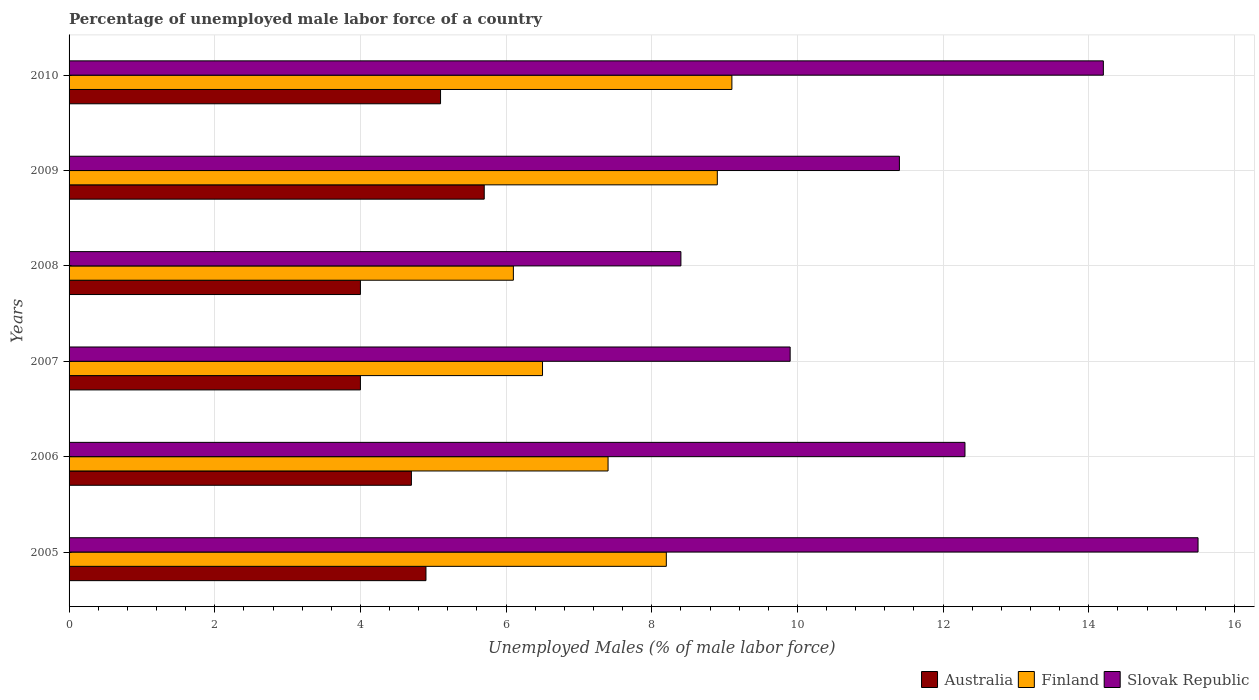How many groups of bars are there?
Keep it short and to the point. 6. Are the number of bars on each tick of the Y-axis equal?
Provide a succinct answer. Yes. How many bars are there on the 6th tick from the top?
Your answer should be compact. 3. What is the label of the 1st group of bars from the top?
Keep it short and to the point. 2010. In how many cases, is the number of bars for a given year not equal to the number of legend labels?
Give a very brief answer. 0. What is the percentage of unemployed male labor force in Australia in 2010?
Offer a very short reply. 5.1. Across all years, what is the maximum percentage of unemployed male labor force in Finland?
Offer a terse response. 9.1. Across all years, what is the minimum percentage of unemployed male labor force in Australia?
Provide a short and direct response. 4. What is the total percentage of unemployed male labor force in Australia in the graph?
Your answer should be very brief. 28.4. What is the difference between the percentage of unemployed male labor force in Australia in 2007 and that in 2010?
Provide a succinct answer. -1.1. What is the difference between the percentage of unemployed male labor force in Slovak Republic in 2006 and the percentage of unemployed male labor force in Finland in 2009?
Ensure brevity in your answer.  3.4. What is the average percentage of unemployed male labor force in Slovak Republic per year?
Offer a very short reply. 11.95. In the year 2008, what is the difference between the percentage of unemployed male labor force in Finland and percentage of unemployed male labor force in Slovak Republic?
Offer a terse response. -2.3. In how many years, is the percentage of unemployed male labor force in Australia greater than 9.6 %?
Make the answer very short. 0. What is the ratio of the percentage of unemployed male labor force in Finland in 2006 to that in 2008?
Give a very brief answer. 1.21. What is the difference between the highest and the second highest percentage of unemployed male labor force in Australia?
Your response must be concise. 0.6. What is the difference between the highest and the lowest percentage of unemployed male labor force in Finland?
Offer a very short reply. 3. In how many years, is the percentage of unemployed male labor force in Slovak Republic greater than the average percentage of unemployed male labor force in Slovak Republic taken over all years?
Your answer should be compact. 3. Is the sum of the percentage of unemployed male labor force in Australia in 2005 and 2007 greater than the maximum percentage of unemployed male labor force in Slovak Republic across all years?
Make the answer very short. No. How many bars are there?
Offer a terse response. 18. Are all the bars in the graph horizontal?
Keep it short and to the point. Yes. Are the values on the major ticks of X-axis written in scientific E-notation?
Your answer should be compact. No. Does the graph contain grids?
Your answer should be compact. Yes. How are the legend labels stacked?
Your answer should be very brief. Horizontal. What is the title of the graph?
Make the answer very short. Percentage of unemployed male labor force of a country. What is the label or title of the X-axis?
Provide a short and direct response. Unemployed Males (% of male labor force). What is the label or title of the Y-axis?
Provide a succinct answer. Years. What is the Unemployed Males (% of male labor force) of Australia in 2005?
Keep it short and to the point. 4.9. What is the Unemployed Males (% of male labor force) of Finland in 2005?
Provide a short and direct response. 8.2. What is the Unemployed Males (% of male labor force) of Australia in 2006?
Give a very brief answer. 4.7. What is the Unemployed Males (% of male labor force) in Finland in 2006?
Your answer should be compact. 7.4. What is the Unemployed Males (% of male labor force) of Slovak Republic in 2006?
Keep it short and to the point. 12.3. What is the Unemployed Males (% of male labor force) in Australia in 2007?
Ensure brevity in your answer.  4. What is the Unemployed Males (% of male labor force) of Slovak Republic in 2007?
Give a very brief answer. 9.9. What is the Unemployed Males (% of male labor force) of Australia in 2008?
Your answer should be compact. 4. What is the Unemployed Males (% of male labor force) in Finland in 2008?
Make the answer very short. 6.1. What is the Unemployed Males (% of male labor force) in Slovak Republic in 2008?
Provide a succinct answer. 8.4. What is the Unemployed Males (% of male labor force) in Australia in 2009?
Provide a succinct answer. 5.7. What is the Unemployed Males (% of male labor force) of Finland in 2009?
Your response must be concise. 8.9. What is the Unemployed Males (% of male labor force) of Slovak Republic in 2009?
Give a very brief answer. 11.4. What is the Unemployed Males (% of male labor force) in Australia in 2010?
Offer a terse response. 5.1. What is the Unemployed Males (% of male labor force) of Finland in 2010?
Give a very brief answer. 9.1. What is the Unemployed Males (% of male labor force) of Slovak Republic in 2010?
Your answer should be compact. 14.2. Across all years, what is the maximum Unemployed Males (% of male labor force) of Australia?
Make the answer very short. 5.7. Across all years, what is the maximum Unemployed Males (% of male labor force) of Finland?
Offer a very short reply. 9.1. Across all years, what is the maximum Unemployed Males (% of male labor force) in Slovak Republic?
Make the answer very short. 15.5. Across all years, what is the minimum Unemployed Males (% of male labor force) in Australia?
Your answer should be compact. 4. Across all years, what is the minimum Unemployed Males (% of male labor force) of Finland?
Give a very brief answer. 6.1. Across all years, what is the minimum Unemployed Males (% of male labor force) in Slovak Republic?
Offer a terse response. 8.4. What is the total Unemployed Males (% of male labor force) of Australia in the graph?
Your response must be concise. 28.4. What is the total Unemployed Males (% of male labor force) of Finland in the graph?
Your response must be concise. 46.2. What is the total Unemployed Males (% of male labor force) of Slovak Republic in the graph?
Keep it short and to the point. 71.7. What is the difference between the Unemployed Males (% of male labor force) of Australia in 2005 and that in 2006?
Ensure brevity in your answer.  0.2. What is the difference between the Unemployed Males (% of male labor force) of Slovak Republic in 2005 and that in 2006?
Offer a very short reply. 3.2. What is the difference between the Unemployed Males (% of male labor force) of Australia in 2005 and that in 2007?
Offer a very short reply. 0.9. What is the difference between the Unemployed Males (% of male labor force) in Finland in 2005 and that in 2007?
Ensure brevity in your answer.  1.7. What is the difference between the Unemployed Males (% of male labor force) in Australia in 2005 and that in 2009?
Provide a short and direct response. -0.8. What is the difference between the Unemployed Males (% of male labor force) of Finland in 2005 and that in 2009?
Offer a very short reply. -0.7. What is the difference between the Unemployed Males (% of male labor force) in Australia in 2005 and that in 2010?
Make the answer very short. -0.2. What is the difference between the Unemployed Males (% of male labor force) of Slovak Republic in 2005 and that in 2010?
Offer a terse response. 1.3. What is the difference between the Unemployed Males (% of male labor force) in Australia in 2006 and that in 2007?
Your answer should be compact. 0.7. What is the difference between the Unemployed Males (% of male labor force) in Finland in 2006 and that in 2007?
Your answer should be very brief. 0.9. What is the difference between the Unemployed Males (% of male labor force) of Slovak Republic in 2006 and that in 2008?
Ensure brevity in your answer.  3.9. What is the difference between the Unemployed Males (% of male labor force) of Australia in 2006 and that in 2009?
Your response must be concise. -1. What is the difference between the Unemployed Males (% of male labor force) in Australia in 2006 and that in 2010?
Make the answer very short. -0.4. What is the difference between the Unemployed Males (% of male labor force) in Slovak Republic in 2006 and that in 2010?
Provide a short and direct response. -1.9. What is the difference between the Unemployed Males (% of male labor force) in Australia in 2007 and that in 2008?
Offer a very short reply. 0. What is the difference between the Unemployed Males (% of male labor force) in Finland in 2007 and that in 2008?
Give a very brief answer. 0.4. What is the difference between the Unemployed Males (% of male labor force) of Slovak Republic in 2007 and that in 2008?
Keep it short and to the point. 1.5. What is the difference between the Unemployed Males (% of male labor force) in Slovak Republic in 2007 and that in 2009?
Your response must be concise. -1.5. What is the difference between the Unemployed Males (% of male labor force) in Australia in 2007 and that in 2010?
Keep it short and to the point. -1.1. What is the difference between the Unemployed Males (% of male labor force) of Slovak Republic in 2007 and that in 2010?
Your response must be concise. -4.3. What is the difference between the Unemployed Males (% of male labor force) of Finland in 2008 and that in 2009?
Your response must be concise. -2.8. What is the difference between the Unemployed Males (% of male labor force) of Slovak Republic in 2008 and that in 2009?
Offer a terse response. -3. What is the difference between the Unemployed Males (% of male labor force) of Australia in 2008 and that in 2010?
Ensure brevity in your answer.  -1.1. What is the difference between the Unemployed Males (% of male labor force) in Finland in 2008 and that in 2010?
Ensure brevity in your answer.  -3. What is the difference between the Unemployed Males (% of male labor force) of Slovak Republic in 2008 and that in 2010?
Provide a succinct answer. -5.8. What is the difference between the Unemployed Males (% of male labor force) of Australia in 2009 and that in 2010?
Give a very brief answer. 0.6. What is the difference between the Unemployed Males (% of male labor force) in Finland in 2009 and that in 2010?
Make the answer very short. -0.2. What is the difference between the Unemployed Males (% of male labor force) in Slovak Republic in 2009 and that in 2010?
Make the answer very short. -2.8. What is the difference between the Unemployed Males (% of male labor force) of Australia in 2005 and the Unemployed Males (% of male labor force) of Finland in 2006?
Offer a terse response. -2.5. What is the difference between the Unemployed Males (% of male labor force) of Finland in 2005 and the Unemployed Males (% of male labor force) of Slovak Republic in 2006?
Make the answer very short. -4.1. What is the difference between the Unemployed Males (% of male labor force) in Australia in 2005 and the Unemployed Males (% of male labor force) in Finland in 2007?
Provide a succinct answer. -1.6. What is the difference between the Unemployed Males (% of male labor force) of Australia in 2005 and the Unemployed Males (% of male labor force) of Slovak Republic in 2008?
Make the answer very short. -3.5. What is the difference between the Unemployed Males (% of male labor force) of Finland in 2005 and the Unemployed Males (% of male labor force) of Slovak Republic in 2008?
Provide a short and direct response. -0.2. What is the difference between the Unemployed Males (% of male labor force) of Australia in 2005 and the Unemployed Males (% of male labor force) of Finland in 2009?
Provide a succinct answer. -4. What is the difference between the Unemployed Males (% of male labor force) in Finland in 2005 and the Unemployed Males (% of male labor force) in Slovak Republic in 2009?
Your response must be concise. -3.2. What is the difference between the Unemployed Males (% of male labor force) of Australia in 2005 and the Unemployed Males (% of male labor force) of Finland in 2010?
Your response must be concise. -4.2. What is the difference between the Unemployed Males (% of male labor force) in Finland in 2005 and the Unemployed Males (% of male labor force) in Slovak Republic in 2010?
Ensure brevity in your answer.  -6. What is the difference between the Unemployed Males (% of male labor force) of Australia in 2006 and the Unemployed Males (% of male labor force) of Finland in 2007?
Offer a terse response. -1.8. What is the difference between the Unemployed Males (% of male labor force) of Australia in 2006 and the Unemployed Males (% of male labor force) of Slovak Republic in 2007?
Provide a short and direct response. -5.2. What is the difference between the Unemployed Males (% of male labor force) in Finland in 2006 and the Unemployed Males (% of male labor force) in Slovak Republic in 2007?
Provide a short and direct response. -2.5. What is the difference between the Unemployed Males (% of male labor force) in Finland in 2006 and the Unemployed Males (% of male labor force) in Slovak Republic in 2008?
Your answer should be very brief. -1. What is the difference between the Unemployed Males (% of male labor force) in Australia in 2006 and the Unemployed Males (% of male labor force) in Finland in 2009?
Make the answer very short. -4.2. What is the difference between the Unemployed Males (% of male labor force) of Australia in 2007 and the Unemployed Males (% of male labor force) of Slovak Republic in 2008?
Give a very brief answer. -4.4. What is the difference between the Unemployed Males (% of male labor force) of Australia in 2007 and the Unemployed Males (% of male labor force) of Slovak Republic in 2009?
Offer a terse response. -7.4. What is the difference between the Unemployed Males (% of male labor force) of Finland in 2007 and the Unemployed Males (% of male labor force) of Slovak Republic in 2009?
Offer a terse response. -4.9. What is the difference between the Unemployed Males (% of male labor force) of Australia in 2007 and the Unemployed Males (% of male labor force) of Finland in 2010?
Give a very brief answer. -5.1. What is the difference between the Unemployed Males (% of male labor force) of Australia in 2008 and the Unemployed Males (% of male labor force) of Finland in 2009?
Ensure brevity in your answer.  -4.9. What is the difference between the Unemployed Males (% of male labor force) in Finland in 2008 and the Unemployed Males (% of male labor force) in Slovak Republic in 2009?
Provide a short and direct response. -5.3. What is the difference between the Unemployed Males (% of male labor force) of Finland in 2008 and the Unemployed Males (% of male labor force) of Slovak Republic in 2010?
Provide a short and direct response. -8.1. What is the average Unemployed Males (% of male labor force) in Australia per year?
Give a very brief answer. 4.73. What is the average Unemployed Males (% of male labor force) of Finland per year?
Keep it short and to the point. 7.7. What is the average Unemployed Males (% of male labor force) of Slovak Republic per year?
Keep it short and to the point. 11.95. In the year 2005, what is the difference between the Unemployed Males (% of male labor force) of Finland and Unemployed Males (% of male labor force) of Slovak Republic?
Your response must be concise. -7.3. In the year 2006, what is the difference between the Unemployed Males (% of male labor force) in Australia and Unemployed Males (% of male labor force) in Finland?
Your answer should be very brief. -2.7. In the year 2006, what is the difference between the Unemployed Males (% of male labor force) of Australia and Unemployed Males (% of male labor force) of Slovak Republic?
Ensure brevity in your answer.  -7.6. In the year 2006, what is the difference between the Unemployed Males (% of male labor force) in Finland and Unemployed Males (% of male labor force) in Slovak Republic?
Your response must be concise. -4.9. In the year 2007, what is the difference between the Unemployed Males (% of male labor force) in Australia and Unemployed Males (% of male labor force) in Finland?
Make the answer very short. -2.5. In the year 2007, what is the difference between the Unemployed Males (% of male labor force) of Finland and Unemployed Males (% of male labor force) of Slovak Republic?
Your answer should be compact. -3.4. In the year 2008, what is the difference between the Unemployed Males (% of male labor force) in Australia and Unemployed Males (% of male labor force) in Finland?
Provide a short and direct response. -2.1. In the year 2008, what is the difference between the Unemployed Males (% of male labor force) of Finland and Unemployed Males (% of male labor force) of Slovak Republic?
Your answer should be very brief. -2.3. In the year 2009, what is the difference between the Unemployed Males (% of male labor force) of Australia and Unemployed Males (% of male labor force) of Finland?
Make the answer very short. -3.2. In the year 2009, what is the difference between the Unemployed Males (% of male labor force) of Australia and Unemployed Males (% of male labor force) of Slovak Republic?
Offer a very short reply. -5.7. In the year 2009, what is the difference between the Unemployed Males (% of male labor force) of Finland and Unemployed Males (% of male labor force) of Slovak Republic?
Your answer should be compact. -2.5. In the year 2010, what is the difference between the Unemployed Males (% of male labor force) in Australia and Unemployed Males (% of male labor force) in Slovak Republic?
Give a very brief answer. -9.1. What is the ratio of the Unemployed Males (% of male labor force) of Australia in 2005 to that in 2006?
Your answer should be very brief. 1.04. What is the ratio of the Unemployed Males (% of male labor force) of Finland in 2005 to that in 2006?
Provide a short and direct response. 1.11. What is the ratio of the Unemployed Males (% of male labor force) in Slovak Republic in 2005 to that in 2006?
Keep it short and to the point. 1.26. What is the ratio of the Unemployed Males (% of male labor force) in Australia in 2005 to that in 2007?
Your response must be concise. 1.23. What is the ratio of the Unemployed Males (% of male labor force) in Finland in 2005 to that in 2007?
Your answer should be very brief. 1.26. What is the ratio of the Unemployed Males (% of male labor force) of Slovak Republic in 2005 to that in 2007?
Your response must be concise. 1.57. What is the ratio of the Unemployed Males (% of male labor force) in Australia in 2005 to that in 2008?
Provide a short and direct response. 1.23. What is the ratio of the Unemployed Males (% of male labor force) of Finland in 2005 to that in 2008?
Offer a terse response. 1.34. What is the ratio of the Unemployed Males (% of male labor force) in Slovak Republic in 2005 to that in 2008?
Provide a short and direct response. 1.85. What is the ratio of the Unemployed Males (% of male labor force) of Australia in 2005 to that in 2009?
Keep it short and to the point. 0.86. What is the ratio of the Unemployed Males (% of male labor force) in Finland in 2005 to that in 2009?
Your response must be concise. 0.92. What is the ratio of the Unemployed Males (% of male labor force) of Slovak Republic in 2005 to that in 2009?
Provide a short and direct response. 1.36. What is the ratio of the Unemployed Males (% of male labor force) in Australia in 2005 to that in 2010?
Give a very brief answer. 0.96. What is the ratio of the Unemployed Males (% of male labor force) of Finland in 2005 to that in 2010?
Keep it short and to the point. 0.9. What is the ratio of the Unemployed Males (% of male labor force) of Slovak Republic in 2005 to that in 2010?
Ensure brevity in your answer.  1.09. What is the ratio of the Unemployed Males (% of male labor force) of Australia in 2006 to that in 2007?
Make the answer very short. 1.18. What is the ratio of the Unemployed Males (% of male labor force) of Finland in 2006 to that in 2007?
Make the answer very short. 1.14. What is the ratio of the Unemployed Males (% of male labor force) of Slovak Republic in 2006 to that in 2007?
Your answer should be compact. 1.24. What is the ratio of the Unemployed Males (% of male labor force) in Australia in 2006 to that in 2008?
Ensure brevity in your answer.  1.18. What is the ratio of the Unemployed Males (% of male labor force) in Finland in 2006 to that in 2008?
Your answer should be compact. 1.21. What is the ratio of the Unemployed Males (% of male labor force) of Slovak Republic in 2006 to that in 2008?
Your response must be concise. 1.46. What is the ratio of the Unemployed Males (% of male labor force) of Australia in 2006 to that in 2009?
Your answer should be very brief. 0.82. What is the ratio of the Unemployed Males (% of male labor force) of Finland in 2006 to that in 2009?
Your response must be concise. 0.83. What is the ratio of the Unemployed Males (% of male labor force) of Slovak Republic in 2006 to that in 2009?
Make the answer very short. 1.08. What is the ratio of the Unemployed Males (% of male labor force) of Australia in 2006 to that in 2010?
Your answer should be compact. 0.92. What is the ratio of the Unemployed Males (% of male labor force) in Finland in 2006 to that in 2010?
Your answer should be compact. 0.81. What is the ratio of the Unemployed Males (% of male labor force) of Slovak Republic in 2006 to that in 2010?
Offer a terse response. 0.87. What is the ratio of the Unemployed Males (% of male labor force) in Finland in 2007 to that in 2008?
Ensure brevity in your answer.  1.07. What is the ratio of the Unemployed Males (% of male labor force) of Slovak Republic in 2007 to that in 2008?
Your response must be concise. 1.18. What is the ratio of the Unemployed Males (% of male labor force) of Australia in 2007 to that in 2009?
Your answer should be compact. 0.7. What is the ratio of the Unemployed Males (% of male labor force) in Finland in 2007 to that in 2009?
Keep it short and to the point. 0.73. What is the ratio of the Unemployed Males (% of male labor force) of Slovak Republic in 2007 to that in 2009?
Provide a short and direct response. 0.87. What is the ratio of the Unemployed Males (% of male labor force) in Australia in 2007 to that in 2010?
Provide a short and direct response. 0.78. What is the ratio of the Unemployed Males (% of male labor force) of Finland in 2007 to that in 2010?
Give a very brief answer. 0.71. What is the ratio of the Unemployed Males (% of male labor force) in Slovak Republic in 2007 to that in 2010?
Your response must be concise. 0.7. What is the ratio of the Unemployed Males (% of male labor force) of Australia in 2008 to that in 2009?
Your answer should be compact. 0.7. What is the ratio of the Unemployed Males (% of male labor force) in Finland in 2008 to that in 2009?
Give a very brief answer. 0.69. What is the ratio of the Unemployed Males (% of male labor force) of Slovak Republic in 2008 to that in 2009?
Your answer should be compact. 0.74. What is the ratio of the Unemployed Males (% of male labor force) in Australia in 2008 to that in 2010?
Give a very brief answer. 0.78. What is the ratio of the Unemployed Males (% of male labor force) of Finland in 2008 to that in 2010?
Make the answer very short. 0.67. What is the ratio of the Unemployed Males (% of male labor force) of Slovak Republic in 2008 to that in 2010?
Your answer should be very brief. 0.59. What is the ratio of the Unemployed Males (% of male labor force) in Australia in 2009 to that in 2010?
Provide a succinct answer. 1.12. What is the ratio of the Unemployed Males (% of male labor force) in Finland in 2009 to that in 2010?
Keep it short and to the point. 0.98. What is the ratio of the Unemployed Males (% of male labor force) of Slovak Republic in 2009 to that in 2010?
Make the answer very short. 0.8. What is the difference between the highest and the second highest Unemployed Males (% of male labor force) of Australia?
Make the answer very short. 0.6. What is the difference between the highest and the second highest Unemployed Males (% of male labor force) in Slovak Republic?
Offer a terse response. 1.3. 